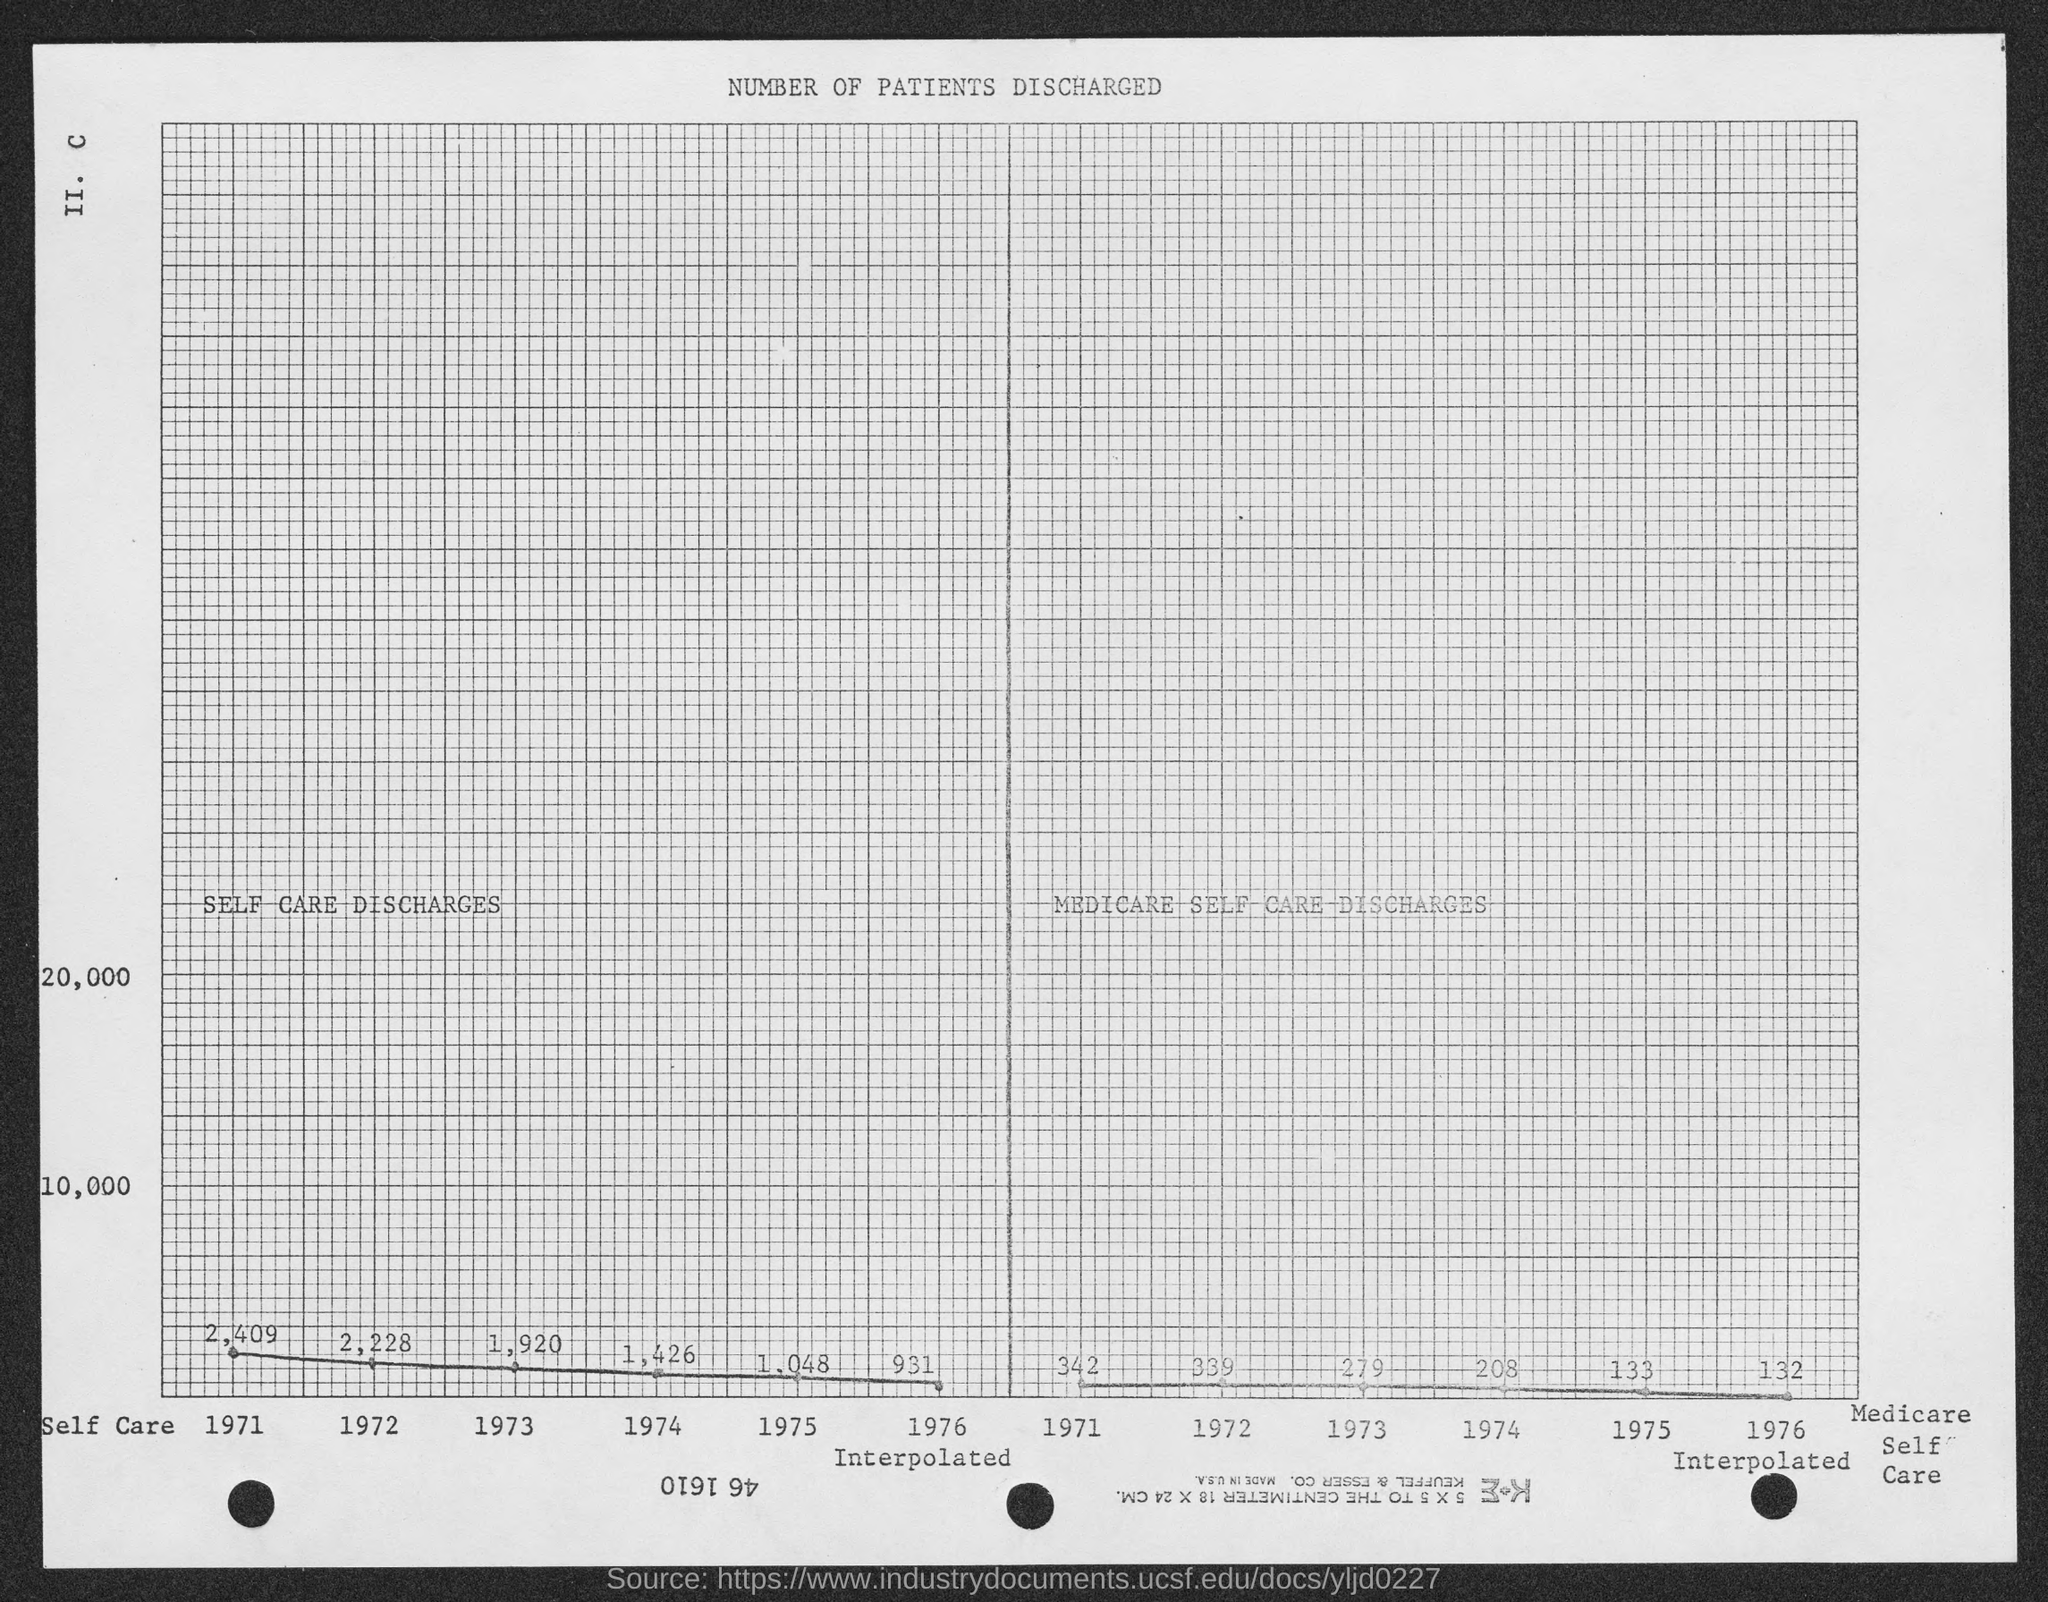What is written at top of the page ?
Give a very brief answer. Number of Patients Discharged. 